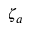<formula> <loc_0><loc_0><loc_500><loc_500>\zeta _ { a }</formula> 